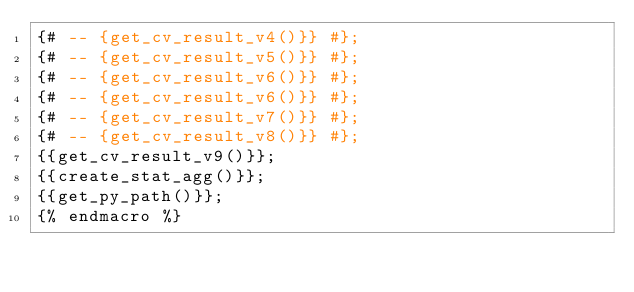Convert code to text. <code><loc_0><loc_0><loc_500><loc_500><_SQL_>{# -- {get_cv_result_v4()}} #};
{# -- {get_cv_result_v5()}} #};
{# -- {get_cv_result_v6()}} #};
{# -- {get_cv_result_v6()}} #};
{# -- {get_cv_result_v7()}} #};
{# -- {get_cv_result_v8()}} #};
{{get_cv_result_v9()}};
{{create_stat_agg()}};
{{get_py_path()}};
{% endmacro %}</code> 